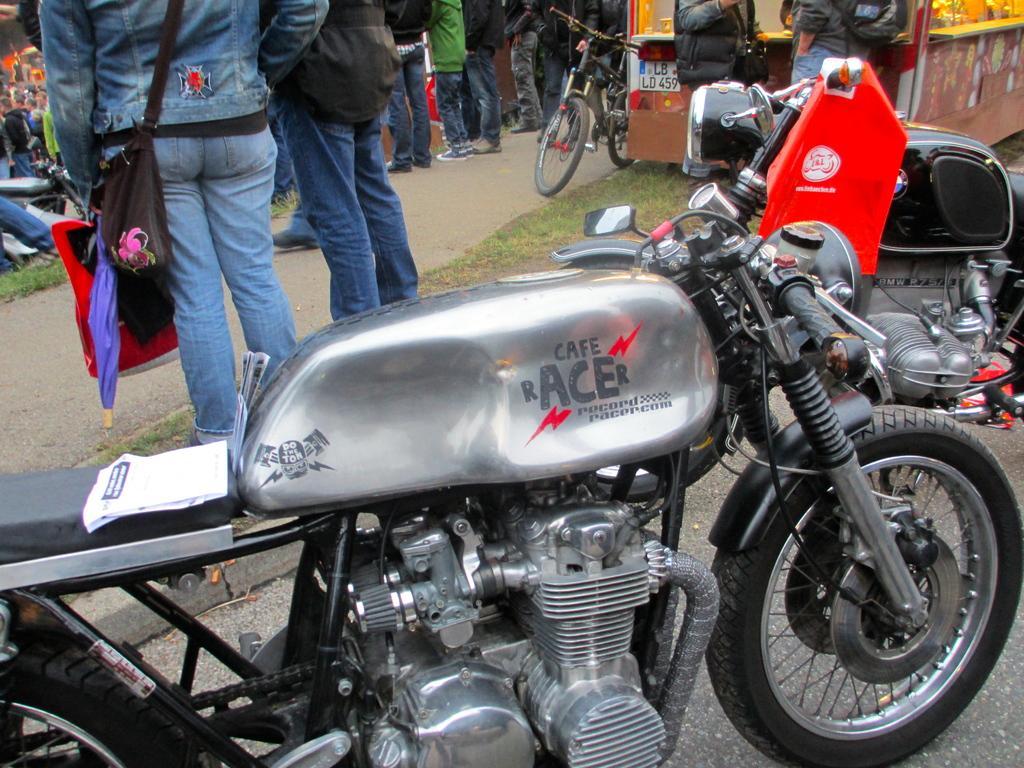Please provide a concise description of this image. In this picture there are vehicles. In the foreground there is a text on the vehicle. At the back there are group of people standing. At the bottom there is a road and there is grass. In the foreground there is a book and there is a cover on the motorbikes. 